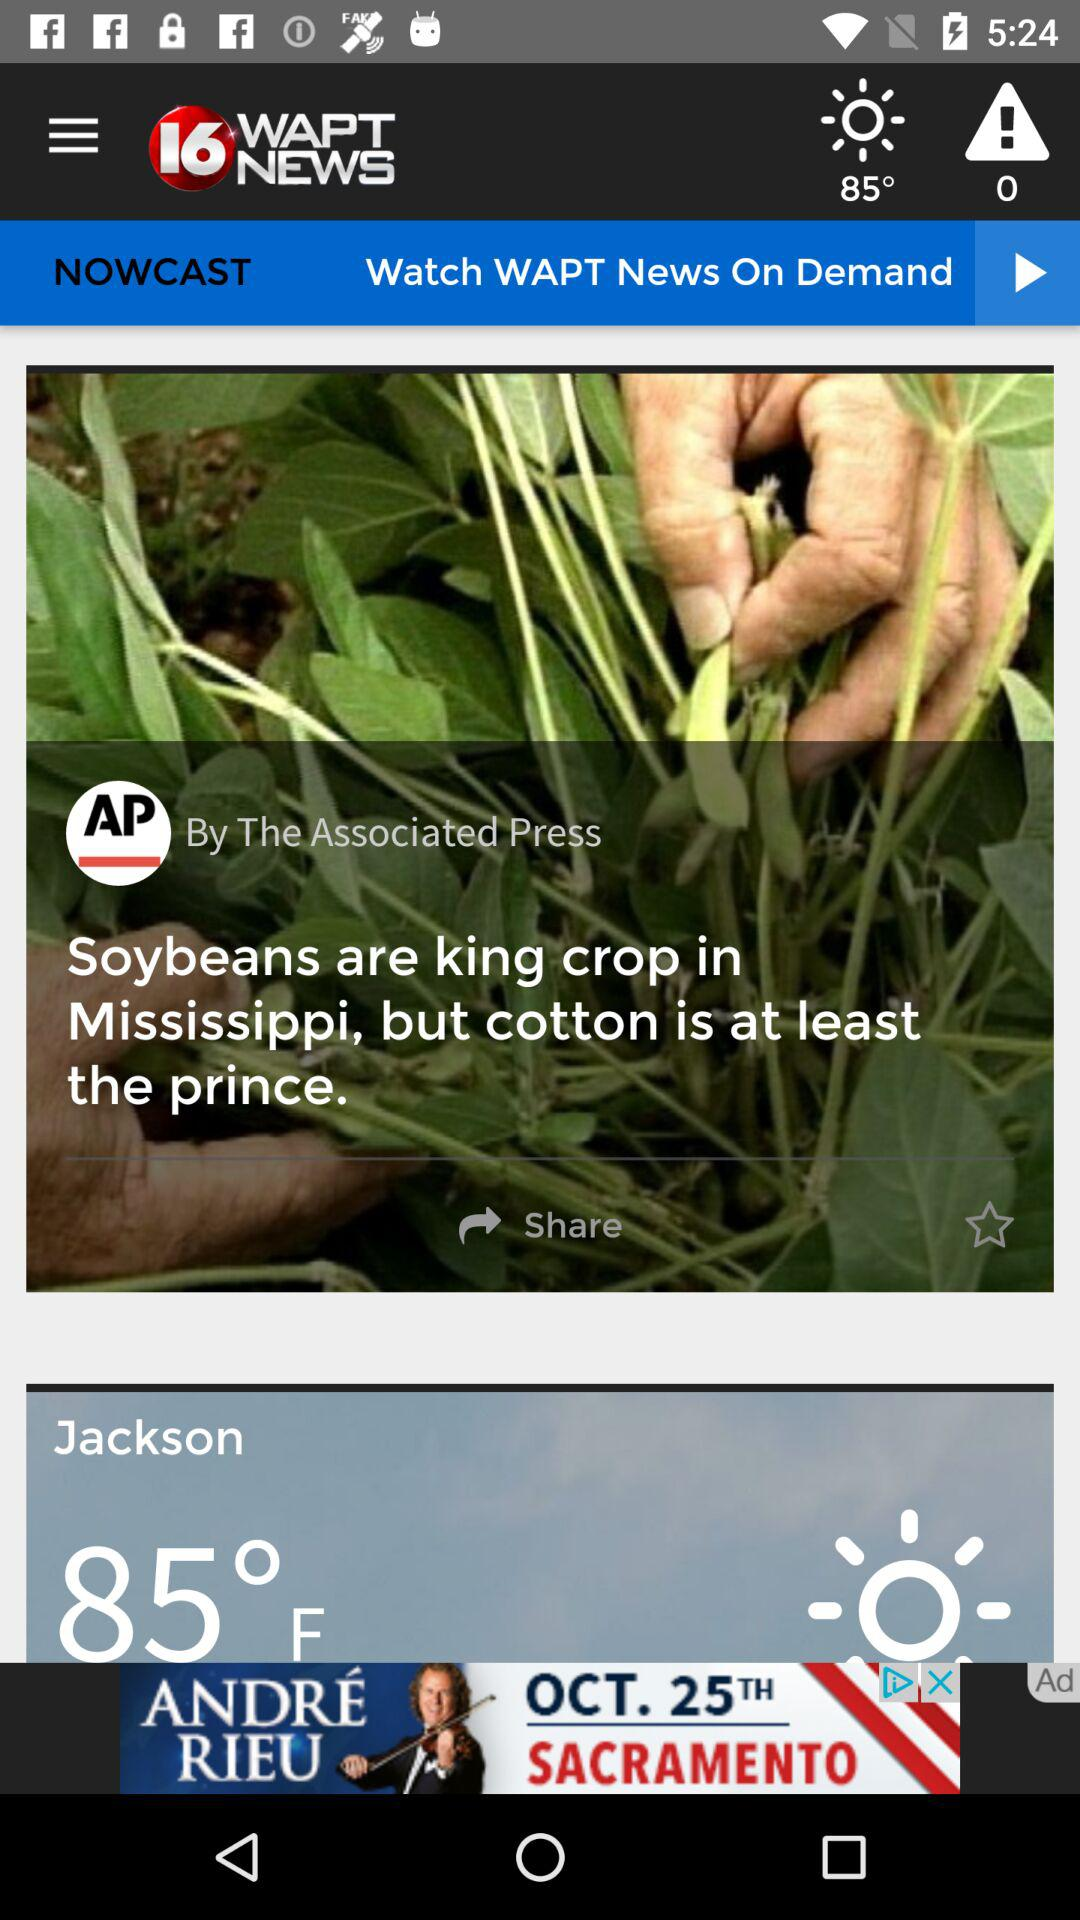What is the name of the application? The name of the application is "16 WAPT NEWS". 